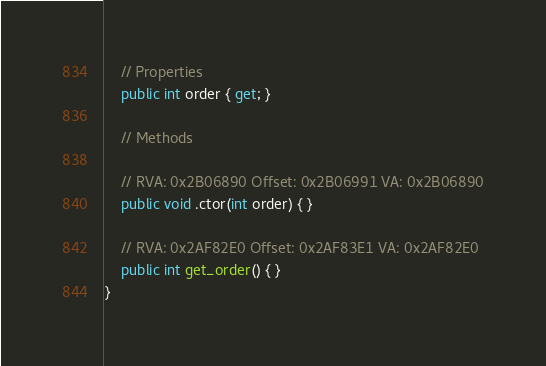Convert code to text. <code><loc_0><loc_0><loc_500><loc_500><_C#_>
	// Properties
	public int order { get; }

	// Methods

	// RVA: 0x2B06890 Offset: 0x2B06991 VA: 0x2B06890
	public void .ctor(int order) { }

	// RVA: 0x2AF82E0 Offset: 0x2AF83E1 VA: 0x2AF82E0
	public int get_order() { }
}

</code> 